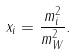<formula> <loc_0><loc_0><loc_500><loc_500>x _ { i } = \frac { m _ { i } ^ { 2 } } { m _ { W } ^ { 2 } } .</formula> 